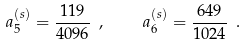<formula> <loc_0><loc_0><loc_500><loc_500>\ a _ { 5 } ^ { ( s ) } = \frac { 1 1 9 } { 4 0 9 6 } \ , \quad \ a _ { 6 } ^ { ( s ) } = \frac { 6 4 9 } { 1 0 2 4 } \ .</formula> 